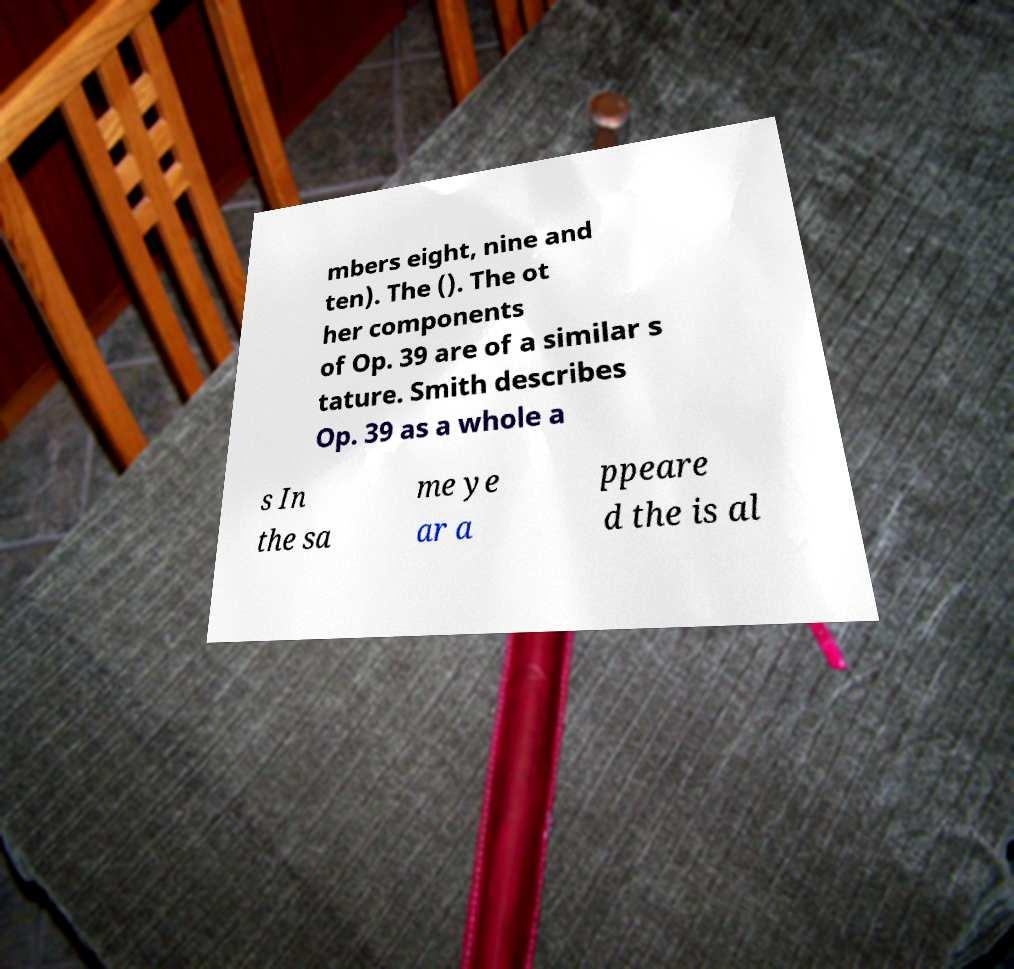There's text embedded in this image that I need extracted. Can you transcribe it verbatim? mbers eight, nine and ten). The (). The ot her components of Op. 39 are of a similar s tature. Smith describes Op. 39 as a whole a s In the sa me ye ar a ppeare d the is al 